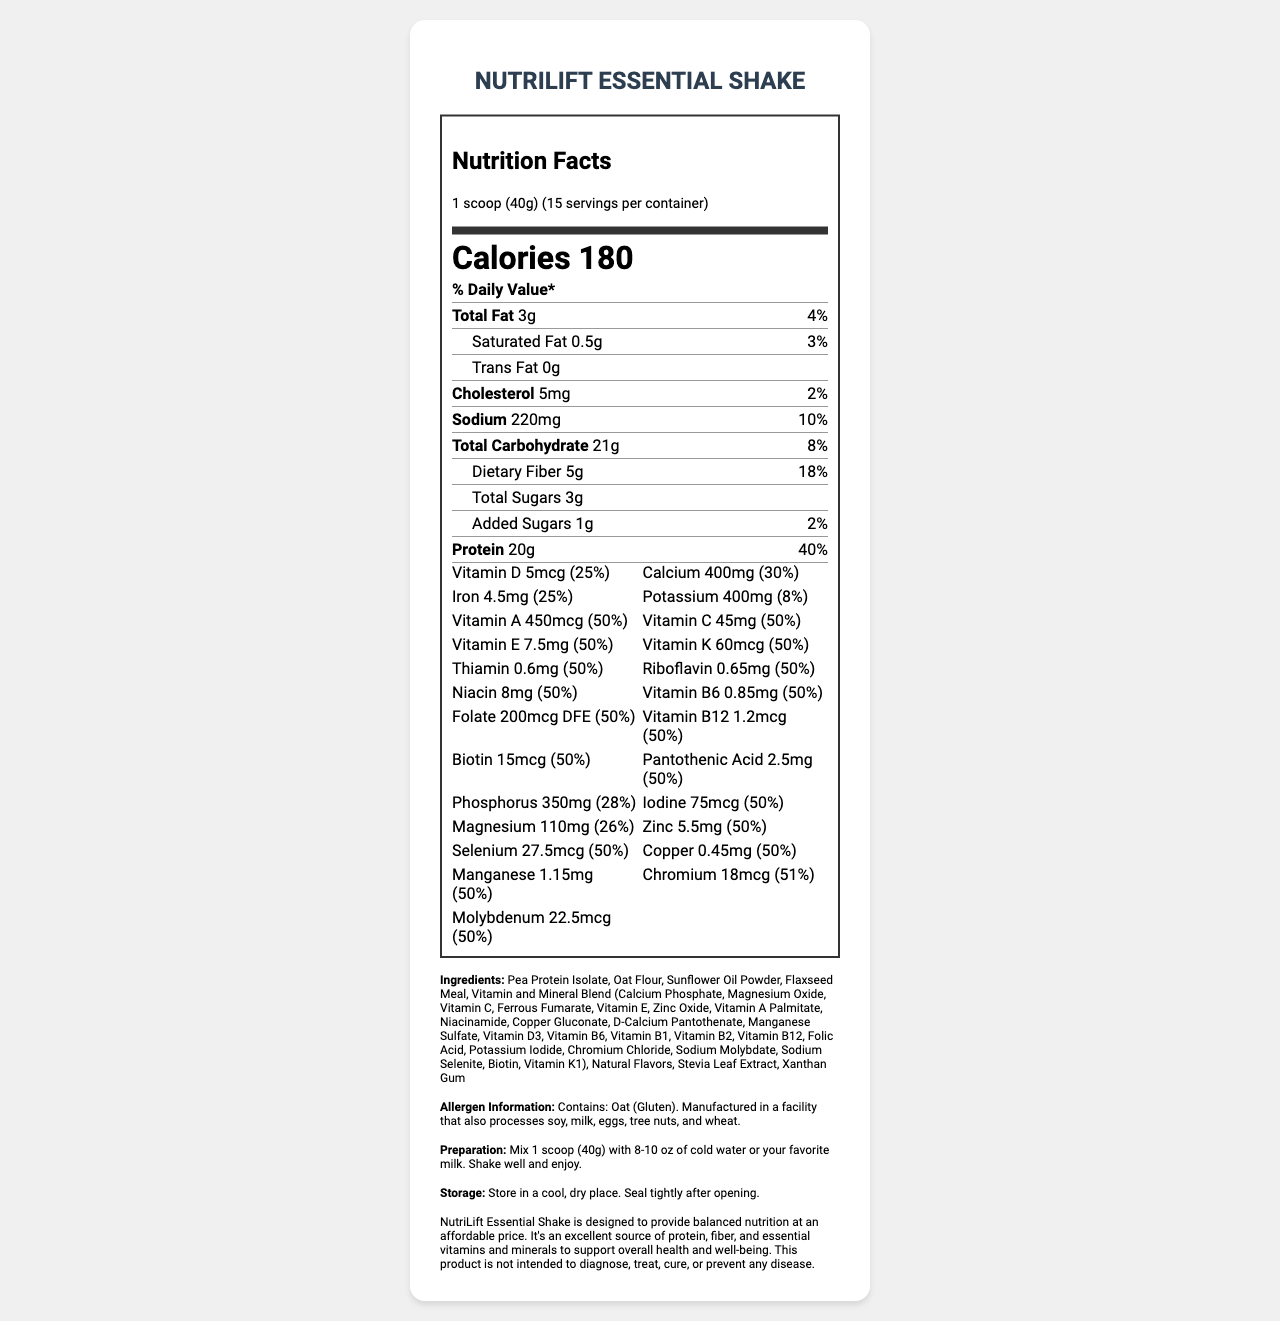What is the name of the product? The product name is listed at the top of the nutrition facts label.
Answer: NutriLift Essential Shake What is the serving size for this meal replacement shake? The serving size is mentioned in the serving info section as "1 scoop (40g)".
Answer: 1 scoop (40g) How many servings are there per container? The document lists that there are 15 servings per container.
Answer: 15 How many calories does one serving provide? The calorie content is prominently displayed in the middle of the document.
Answer: 180 calories What percentage of daily value of protein does one serving provide? The daily value percentage for protein is listed next to the protein amount.
Answer: 40% Which of the following vitamins are provided at 50% daily value per serving? A. Vitamin B12 B. Vitamin A C. Vitamin D D. Vitamin C The vitamins and their daily values are listed in the vitamins section; Vitamin A is provided at 50%.
Answer: B. Vitamin A What is the total fat content per serving? The total fat content per serving is listed at the top of the nutrients section as "Total Fat 3g".
Answer: 3g Does this product contain any trans fat? The nutrient section lists the trans fat content as "0g".
Answer: No How much dietary fiber is in one serving? The document lists the dietary fiber content as "5g".
Answer: 5g What is the daily value percentage of iron provided in one serving? The vitamins and minerals section states that iron is provided at 25% daily value.
Answer: 25% Is this product manufactured in a facility that processes soy? The allergen information states that the product is manufactured in a facility that processes soy.
Answer: Yes Summarize the key nutritional benefits of this product. The summary covers the essential aspects of the document, including calorie content, protein, vitamins, minerals, and fiber.
Answer: NutriLift Essential Shake is a low-cost, nutrient-dense meal replacement shake that provides balanced nutrition. It offers 180 calories, 20g of protein (40% DV), significant amounts of vitamins and minerals, and 5g of dietary fiber (18% DV), making it suitable for supporting overall health and well-being. What is the source of protein in this shake? The ingredient list specifies that Pea Protein Isolate is the source of protein.
Answer: Pea Protein Isolate For those looking to reduce sodium intake, how much sodium does this shake contain per serving? The sodium content per serving is displayed as "220mg", which is 10% of the daily value.
Answer: 220mg How should this product be stored after opening? The storage instructions specify to store in a cool, dry place and to seal tightly after opening.
Answer: Store in a cool, dry place. Seal tightly after opening. Which ingredient is used for sweetening? The ingredient list mentions Stevia Leaf Extract as the sweetener used.
Answer: Stevia Leaf Extract Can we determine if this shake is gluten-free? The allergen information specifies that the product contains Oat (Gluten), and thus it cannot be determined if the shake is entirely gluten-free.
Answer: No 